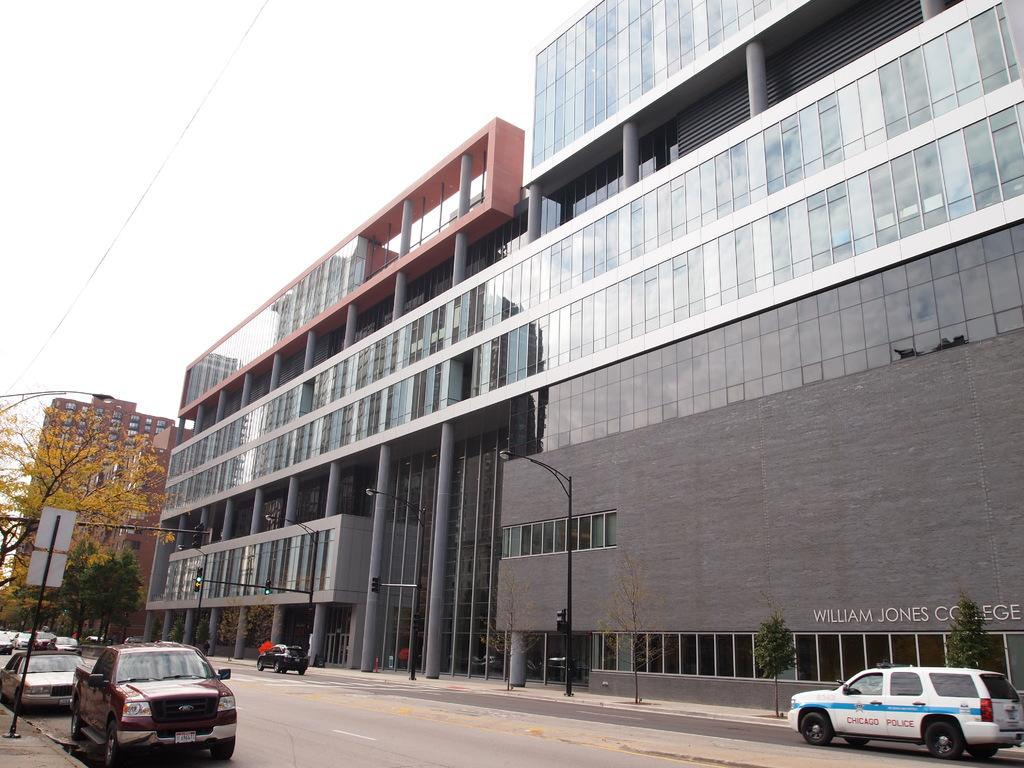What can be seen on the road in the image? There are vehicles on the road in the image. What type of infrastructure is present to provide light at night? Street lights are present in the image. What are the vertical structures visible in the image? Poles are visible in the image. What type of natural elements can be seen in the image? Trees are in the image. What type of man-made structures can be seen in the background? Buildings are in the background of the image. What architectural features can be seen on the buildings? Windows are visible in the background of the image. What type of utility infrastructure is present in the background? Electric wires are present in the background of the image. Is there any text visible in the image? Yes, there is a text written on the wall of a building in the image. What part of the natural environment is visible in the image? The sky is visible in the image. Where is the vase located in the image? There is no vase present in the image. What type of tree is growing on the roof of the building? There is no tree growing on the roof of the building in the image. 